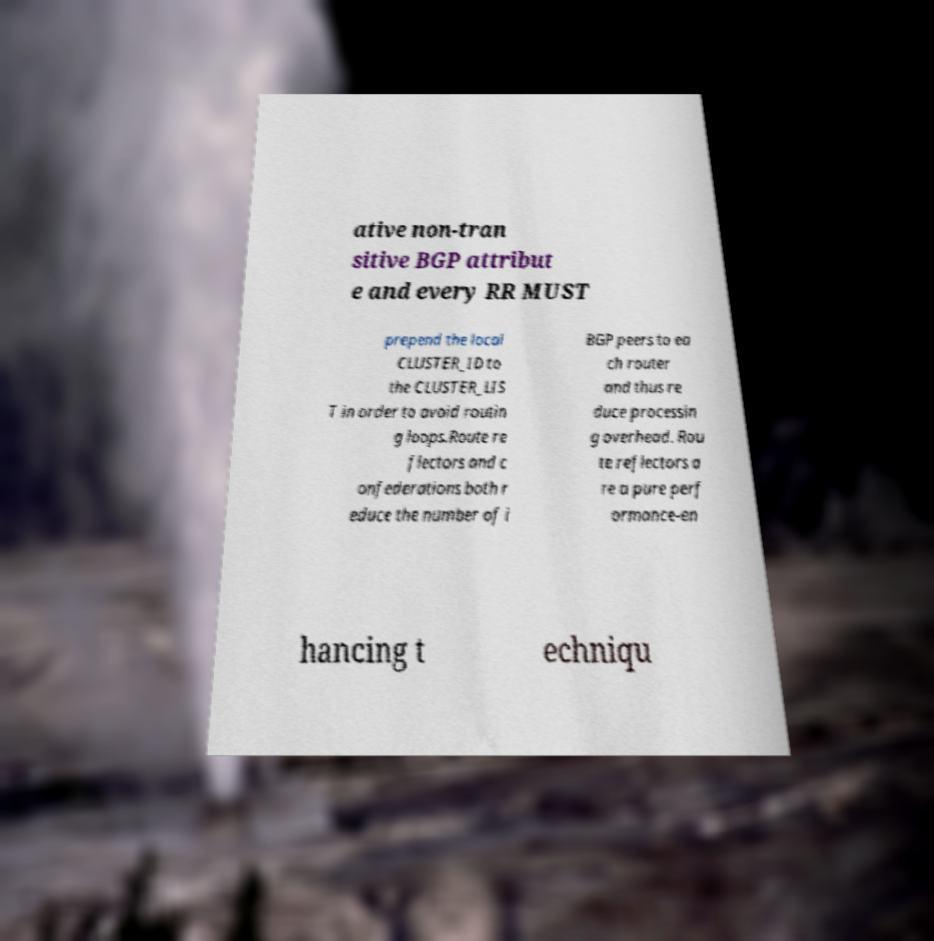Could you extract and type out the text from this image? ative non-tran sitive BGP attribut e and every RR MUST prepend the local CLUSTER_ID to the CLUSTER_LIS T in order to avoid routin g loops.Route re flectors and c onfederations both r educe the number of i BGP peers to ea ch router and thus re duce processin g overhead. Rou te reflectors a re a pure perf ormance-en hancing t echniqu 